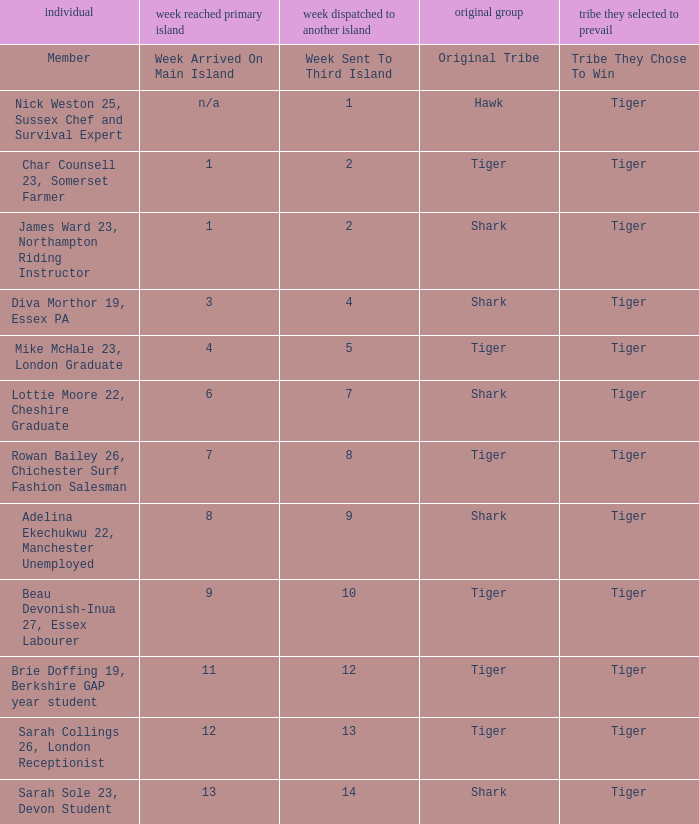What week was the member who arrived on the main island in week 6 sent to the third island? 7.0. 